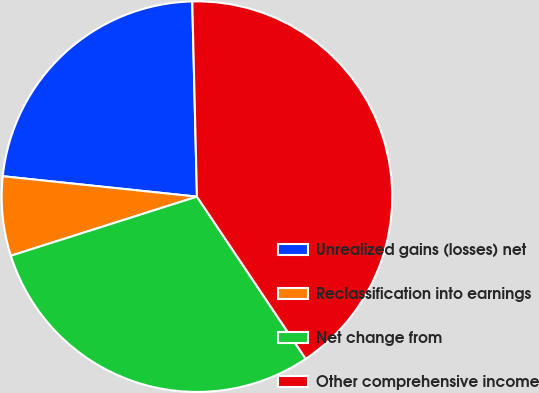<chart> <loc_0><loc_0><loc_500><loc_500><pie_chart><fcel>Unrealized gains (losses) net<fcel>Reclassification into earnings<fcel>Net change from<fcel>Other comprehensive income<nl><fcel>22.95%<fcel>6.56%<fcel>29.51%<fcel>40.98%<nl></chart> 